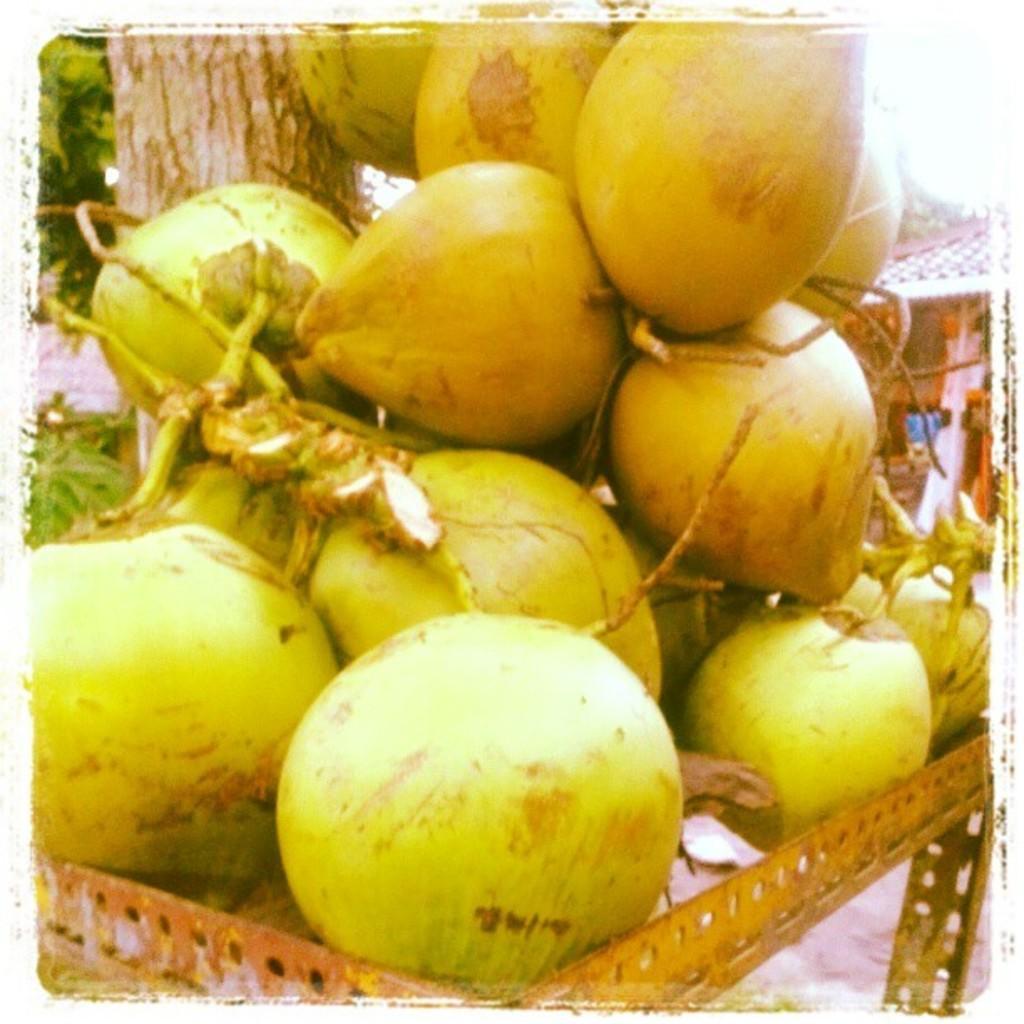How would you summarize this image in a sentence or two? The coconut is highlighted in this picture. There is a group of coconuts on a table. Backside of this coconut there is a tree in green color. These is a store with a rooftop. 